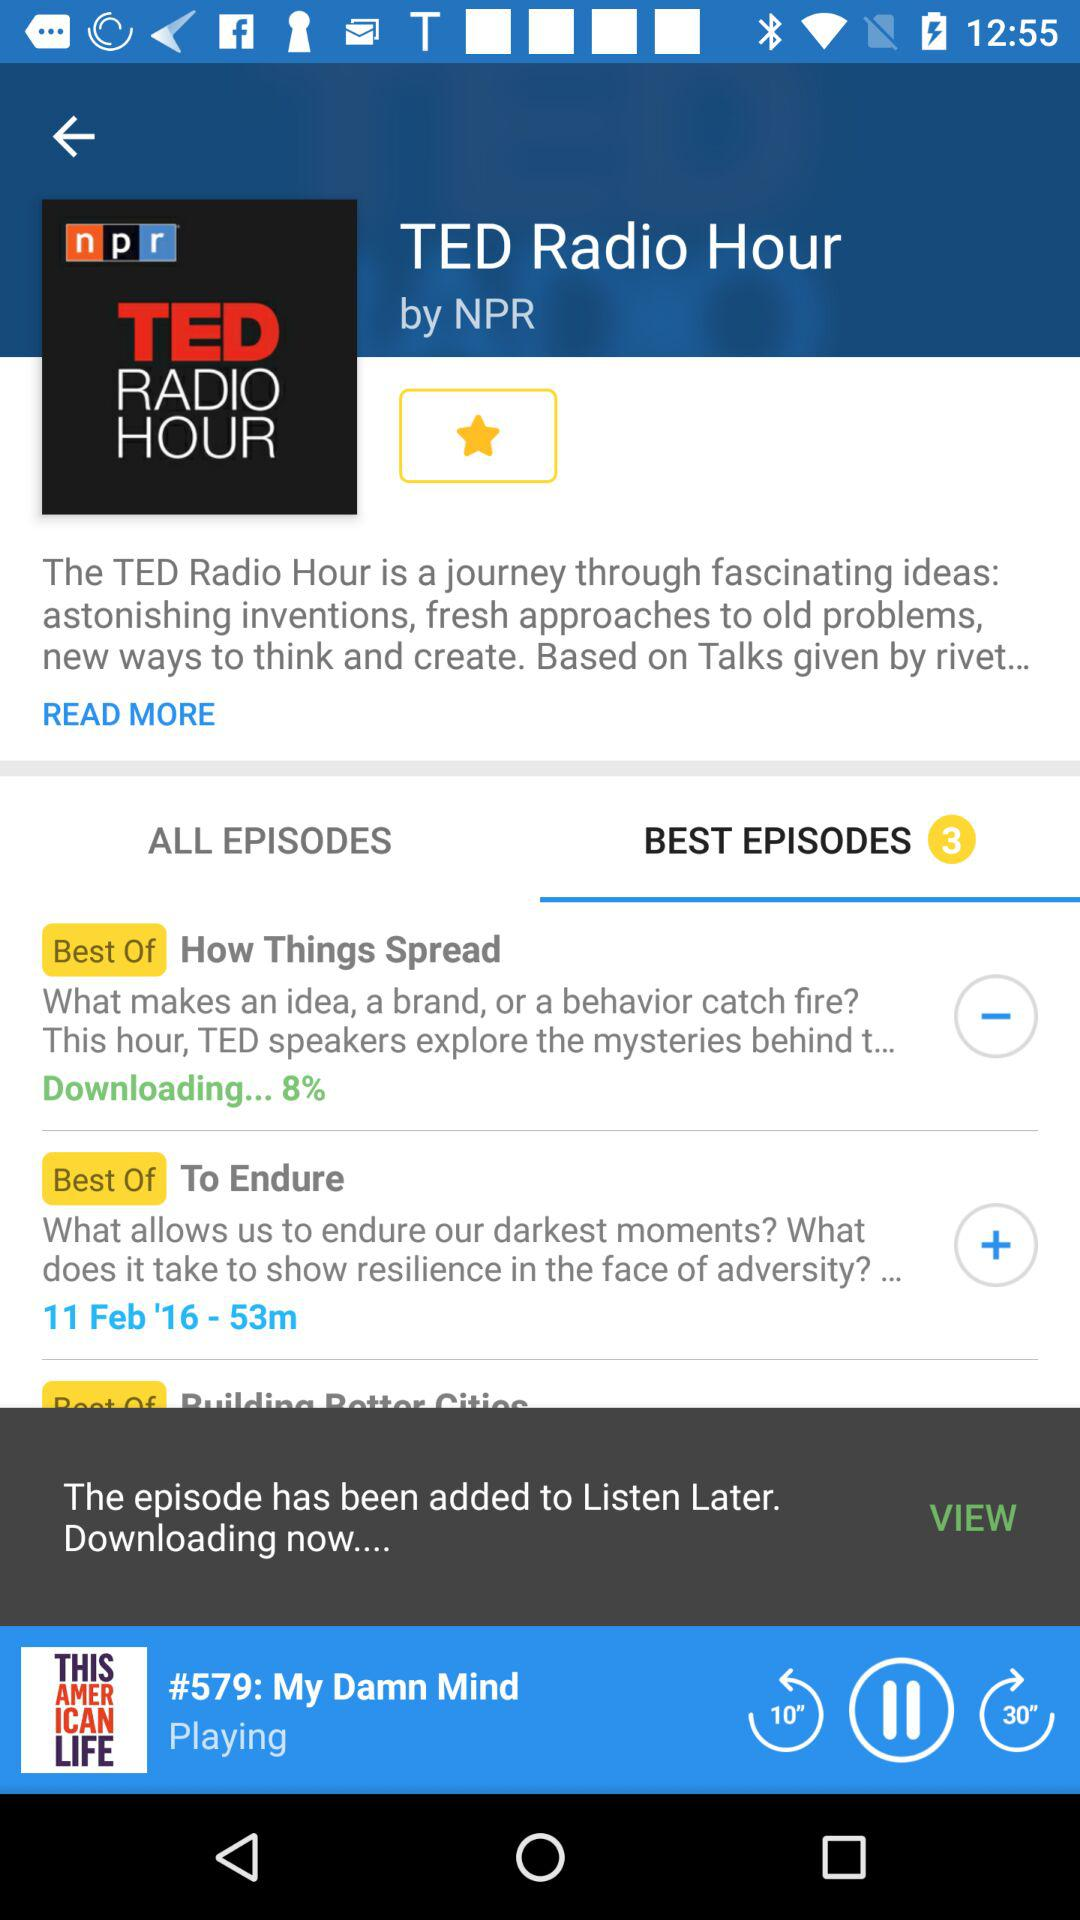What is the upload date of "To Endure"? The upload date of "To Endure" is February 11, 2016. 